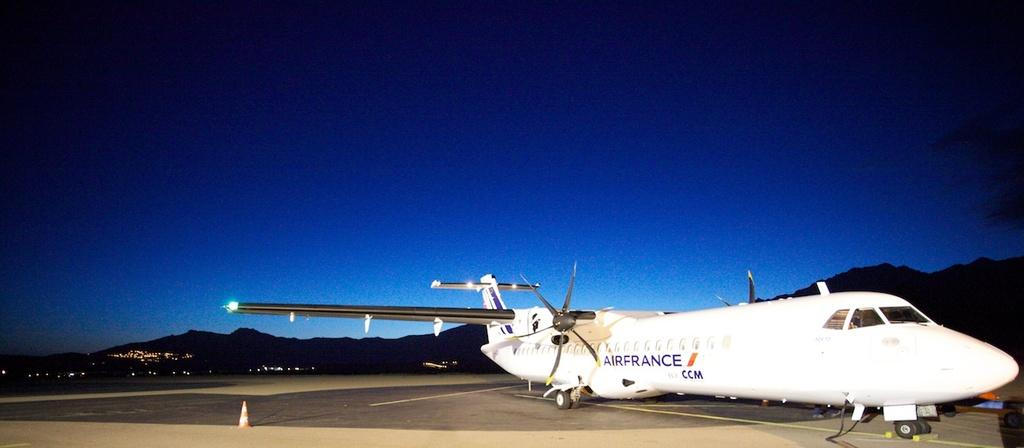<image>
Provide a brief description of the given image. an airfrance plane is on the tarmack, with the night sky behind it 